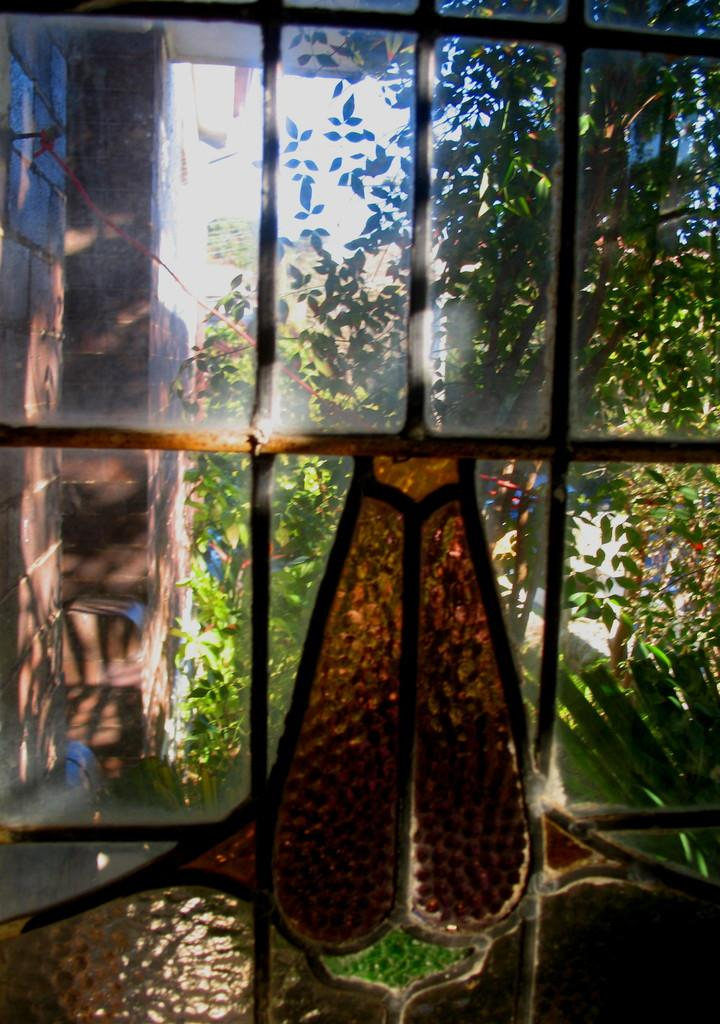What type of structure is visible in the image? The image appears to show a window with a glass door. What is present in front of the window? There is an iron grill in the image. What can be seen through the window? The building wall and trees are visible through the window. What type of thread can be seen in the image? There is no thread present in the image. 